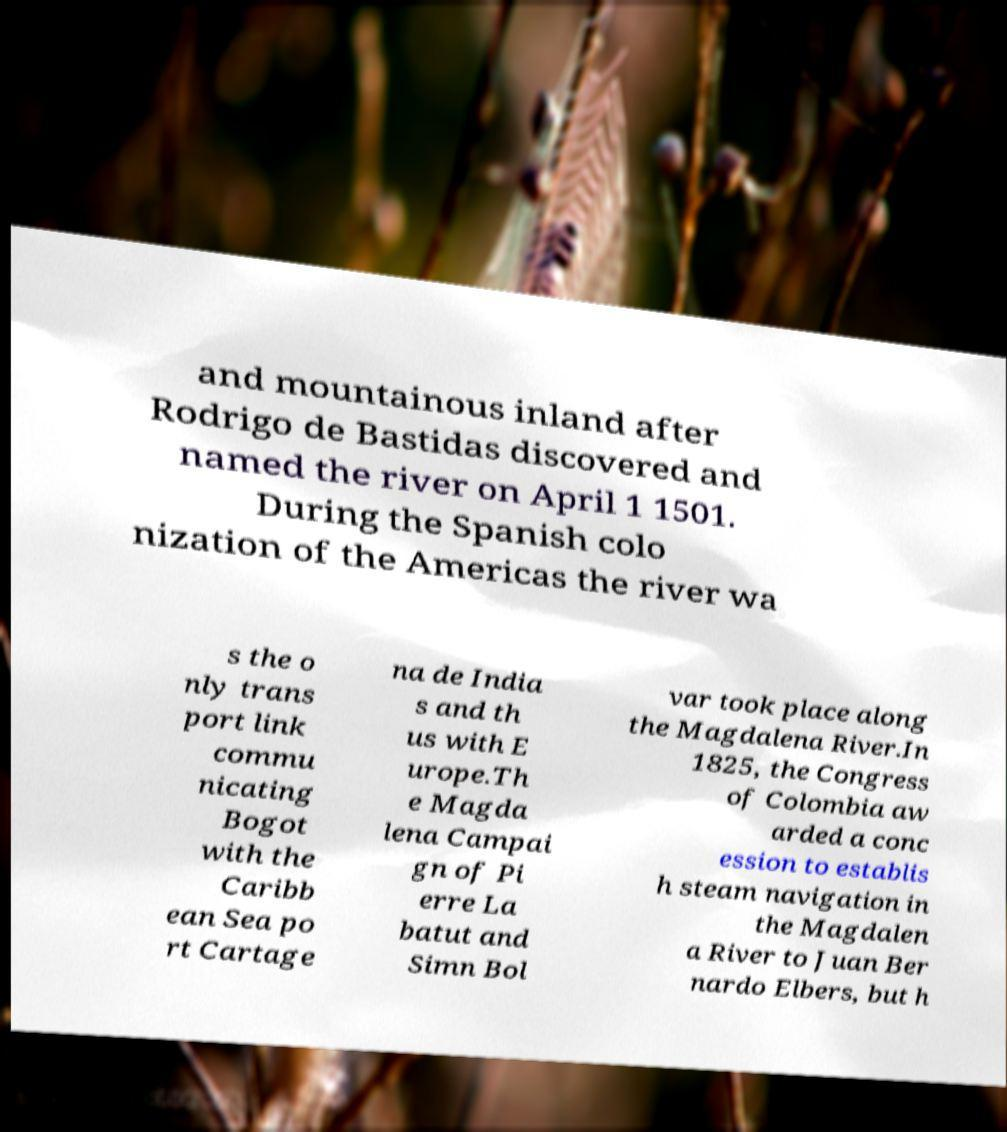There's text embedded in this image that I need extracted. Can you transcribe it verbatim? and mountainous inland after Rodrigo de Bastidas discovered and named the river on April 1 1501. During the Spanish colo nization of the Americas the river wa s the o nly trans port link commu nicating Bogot with the Caribb ean Sea po rt Cartage na de India s and th us with E urope.Th e Magda lena Campai gn of Pi erre La batut and Simn Bol var took place along the Magdalena River.In 1825, the Congress of Colombia aw arded a conc ession to establis h steam navigation in the Magdalen a River to Juan Ber nardo Elbers, but h 